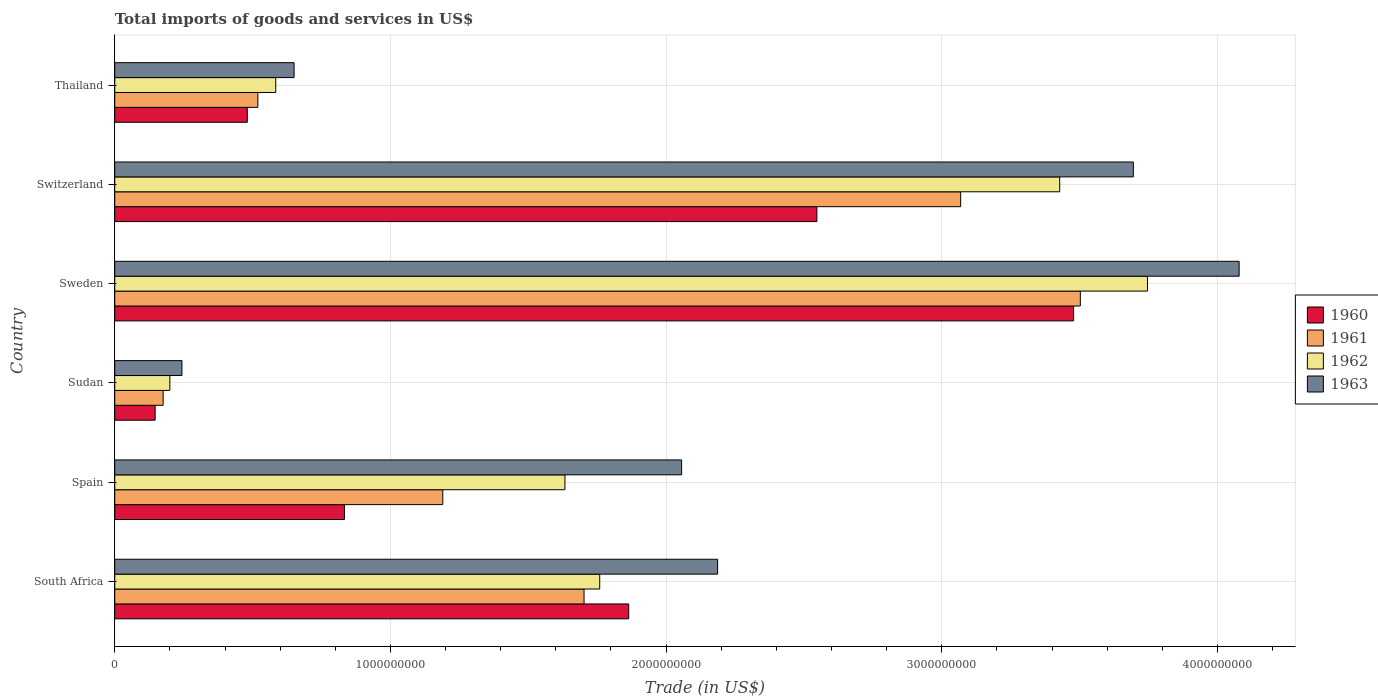How many groups of bars are there?
Keep it short and to the point. 6. Are the number of bars per tick equal to the number of legend labels?
Provide a succinct answer. Yes. Are the number of bars on each tick of the Y-axis equal?
Ensure brevity in your answer.  Yes. How many bars are there on the 5th tick from the top?
Make the answer very short. 4. What is the label of the 6th group of bars from the top?
Your answer should be compact. South Africa. What is the total imports of goods and services in 1963 in Sweden?
Provide a short and direct response. 4.08e+09. Across all countries, what is the maximum total imports of goods and services in 1961?
Ensure brevity in your answer.  3.50e+09. Across all countries, what is the minimum total imports of goods and services in 1960?
Offer a terse response. 1.46e+08. In which country was the total imports of goods and services in 1960 maximum?
Your answer should be compact. Sweden. In which country was the total imports of goods and services in 1961 minimum?
Make the answer very short. Sudan. What is the total total imports of goods and services in 1962 in the graph?
Offer a very short reply. 1.13e+1. What is the difference between the total imports of goods and services in 1962 in Spain and that in Thailand?
Your response must be concise. 1.05e+09. What is the difference between the total imports of goods and services in 1960 in Switzerland and the total imports of goods and services in 1961 in Thailand?
Ensure brevity in your answer.  2.03e+09. What is the average total imports of goods and services in 1962 per country?
Give a very brief answer. 1.89e+09. What is the difference between the total imports of goods and services in 1963 and total imports of goods and services in 1960 in Sweden?
Provide a succinct answer. 6.00e+08. In how many countries, is the total imports of goods and services in 1962 greater than 1000000000 US$?
Your answer should be very brief. 4. What is the ratio of the total imports of goods and services in 1963 in South Africa to that in Switzerland?
Keep it short and to the point. 0.59. What is the difference between the highest and the second highest total imports of goods and services in 1963?
Provide a short and direct response. 3.84e+08. What is the difference between the highest and the lowest total imports of goods and services in 1963?
Your response must be concise. 3.83e+09. Is the sum of the total imports of goods and services in 1963 in Spain and Thailand greater than the maximum total imports of goods and services in 1962 across all countries?
Offer a very short reply. No. What does the 1st bar from the bottom in Thailand represents?
Your answer should be very brief. 1960. Is it the case that in every country, the sum of the total imports of goods and services in 1962 and total imports of goods and services in 1961 is greater than the total imports of goods and services in 1963?
Your response must be concise. Yes. How many countries are there in the graph?
Offer a terse response. 6. Are the values on the major ticks of X-axis written in scientific E-notation?
Provide a succinct answer. No. Does the graph contain any zero values?
Ensure brevity in your answer.  No. Does the graph contain grids?
Ensure brevity in your answer.  Yes. How are the legend labels stacked?
Provide a short and direct response. Vertical. What is the title of the graph?
Give a very brief answer. Total imports of goods and services in US$. What is the label or title of the X-axis?
Offer a terse response. Trade (in US$). What is the Trade (in US$) of 1960 in South Africa?
Offer a very short reply. 1.86e+09. What is the Trade (in US$) in 1961 in South Africa?
Make the answer very short. 1.70e+09. What is the Trade (in US$) in 1962 in South Africa?
Make the answer very short. 1.76e+09. What is the Trade (in US$) of 1963 in South Africa?
Make the answer very short. 2.19e+09. What is the Trade (in US$) in 1960 in Spain?
Give a very brief answer. 8.33e+08. What is the Trade (in US$) of 1961 in Spain?
Your response must be concise. 1.19e+09. What is the Trade (in US$) in 1962 in Spain?
Provide a succinct answer. 1.63e+09. What is the Trade (in US$) in 1963 in Spain?
Offer a terse response. 2.06e+09. What is the Trade (in US$) in 1960 in Sudan?
Ensure brevity in your answer.  1.46e+08. What is the Trade (in US$) in 1961 in Sudan?
Offer a terse response. 1.75e+08. What is the Trade (in US$) of 1962 in Sudan?
Provide a short and direct response. 2.00e+08. What is the Trade (in US$) in 1963 in Sudan?
Provide a succinct answer. 2.44e+08. What is the Trade (in US$) of 1960 in Sweden?
Provide a succinct answer. 3.48e+09. What is the Trade (in US$) of 1961 in Sweden?
Give a very brief answer. 3.50e+09. What is the Trade (in US$) in 1962 in Sweden?
Offer a very short reply. 3.75e+09. What is the Trade (in US$) of 1963 in Sweden?
Make the answer very short. 4.08e+09. What is the Trade (in US$) in 1960 in Switzerland?
Give a very brief answer. 2.55e+09. What is the Trade (in US$) in 1961 in Switzerland?
Give a very brief answer. 3.07e+09. What is the Trade (in US$) of 1962 in Switzerland?
Offer a very short reply. 3.43e+09. What is the Trade (in US$) in 1963 in Switzerland?
Keep it short and to the point. 3.69e+09. What is the Trade (in US$) in 1960 in Thailand?
Give a very brief answer. 4.81e+08. What is the Trade (in US$) of 1961 in Thailand?
Give a very brief answer. 5.19e+08. What is the Trade (in US$) in 1962 in Thailand?
Provide a succinct answer. 5.84e+08. What is the Trade (in US$) in 1963 in Thailand?
Give a very brief answer. 6.51e+08. Across all countries, what is the maximum Trade (in US$) of 1960?
Offer a very short reply. 3.48e+09. Across all countries, what is the maximum Trade (in US$) of 1961?
Offer a terse response. 3.50e+09. Across all countries, what is the maximum Trade (in US$) of 1962?
Your response must be concise. 3.75e+09. Across all countries, what is the maximum Trade (in US$) in 1963?
Your answer should be very brief. 4.08e+09. Across all countries, what is the minimum Trade (in US$) of 1960?
Your answer should be very brief. 1.46e+08. Across all countries, what is the minimum Trade (in US$) of 1961?
Provide a short and direct response. 1.75e+08. Across all countries, what is the minimum Trade (in US$) of 1962?
Provide a succinct answer. 2.00e+08. Across all countries, what is the minimum Trade (in US$) in 1963?
Keep it short and to the point. 2.44e+08. What is the total Trade (in US$) of 1960 in the graph?
Your response must be concise. 9.35e+09. What is the total Trade (in US$) in 1961 in the graph?
Your answer should be compact. 1.02e+1. What is the total Trade (in US$) of 1962 in the graph?
Offer a very short reply. 1.13e+1. What is the total Trade (in US$) in 1963 in the graph?
Provide a short and direct response. 1.29e+1. What is the difference between the Trade (in US$) in 1960 in South Africa and that in Spain?
Ensure brevity in your answer.  1.03e+09. What is the difference between the Trade (in US$) of 1961 in South Africa and that in Spain?
Your answer should be compact. 5.12e+08. What is the difference between the Trade (in US$) in 1962 in South Africa and that in Spain?
Ensure brevity in your answer.  1.26e+08. What is the difference between the Trade (in US$) in 1963 in South Africa and that in Spain?
Keep it short and to the point. 1.31e+08. What is the difference between the Trade (in US$) in 1960 in South Africa and that in Sudan?
Give a very brief answer. 1.72e+09. What is the difference between the Trade (in US$) in 1961 in South Africa and that in Sudan?
Offer a very short reply. 1.53e+09. What is the difference between the Trade (in US$) of 1962 in South Africa and that in Sudan?
Your answer should be very brief. 1.56e+09. What is the difference between the Trade (in US$) in 1963 in South Africa and that in Sudan?
Provide a succinct answer. 1.94e+09. What is the difference between the Trade (in US$) of 1960 in South Africa and that in Sweden?
Offer a very short reply. -1.61e+09. What is the difference between the Trade (in US$) of 1961 in South Africa and that in Sweden?
Offer a terse response. -1.80e+09. What is the difference between the Trade (in US$) in 1962 in South Africa and that in Sweden?
Your response must be concise. -1.99e+09. What is the difference between the Trade (in US$) of 1963 in South Africa and that in Sweden?
Ensure brevity in your answer.  -1.89e+09. What is the difference between the Trade (in US$) of 1960 in South Africa and that in Switzerland?
Offer a very short reply. -6.83e+08. What is the difference between the Trade (in US$) in 1961 in South Africa and that in Switzerland?
Your response must be concise. -1.37e+09. What is the difference between the Trade (in US$) in 1962 in South Africa and that in Switzerland?
Provide a short and direct response. -1.67e+09. What is the difference between the Trade (in US$) of 1963 in South Africa and that in Switzerland?
Offer a terse response. -1.51e+09. What is the difference between the Trade (in US$) in 1960 in South Africa and that in Thailand?
Ensure brevity in your answer.  1.38e+09. What is the difference between the Trade (in US$) of 1961 in South Africa and that in Thailand?
Make the answer very short. 1.18e+09. What is the difference between the Trade (in US$) of 1962 in South Africa and that in Thailand?
Give a very brief answer. 1.18e+09. What is the difference between the Trade (in US$) in 1963 in South Africa and that in Thailand?
Offer a terse response. 1.54e+09. What is the difference between the Trade (in US$) in 1960 in Spain and that in Sudan?
Your answer should be compact. 6.87e+08. What is the difference between the Trade (in US$) in 1961 in Spain and that in Sudan?
Provide a succinct answer. 1.01e+09. What is the difference between the Trade (in US$) in 1962 in Spain and that in Sudan?
Keep it short and to the point. 1.43e+09. What is the difference between the Trade (in US$) of 1963 in Spain and that in Sudan?
Give a very brief answer. 1.81e+09. What is the difference between the Trade (in US$) of 1960 in Spain and that in Sweden?
Keep it short and to the point. -2.65e+09. What is the difference between the Trade (in US$) in 1961 in Spain and that in Sweden?
Offer a very short reply. -2.31e+09. What is the difference between the Trade (in US$) in 1962 in Spain and that in Sweden?
Your answer should be compact. -2.11e+09. What is the difference between the Trade (in US$) in 1963 in Spain and that in Sweden?
Keep it short and to the point. -2.02e+09. What is the difference between the Trade (in US$) of 1960 in Spain and that in Switzerland?
Offer a very short reply. -1.71e+09. What is the difference between the Trade (in US$) of 1961 in Spain and that in Switzerland?
Ensure brevity in your answer.  -1.88e+09. What is the difference between the Trade (in US$) of 1962 in Spain and that in Switzerland?
Your response must be concise. -1.79e+09. What is the difference between the Trade (in US$) in 1963 in Spain and that in Switzerland?
Provide a succinct answer. -1.64e+09. What is the difference between the Trade (in US$) of 1960 in Spain and that in Thailand?
Your response must be concise. 3.52e+08. What is the difference between the Trade (in US$) of 1961 in Spain and that in Thailand?
Provide a short and direct response. 6.71e+08. What is the difference between the Trade (in US$) in 1962 in Spain and that in Thailand?
Your answer should be compact. 1.05e+09. What is the difference between the Trade (in US$) in 1963 in Spain and that in Thailand?
Your answer should be compact. 1.41e+09. What is the difference between the Trade (in US$) of 1960 in Sudan and that in Sweden?
Your answer should be compact. -3.33e+09. What is the difference between the Trade (in US$) of 1961 in Sudan and that in Sweden?
Your answer should be compact. -3.33e+09. What is the difference between the Trade (in US$) of 1962 in Sudan and that in Sweden?
Keep it short and to the point. -3.55e+09. What is the difference between the Trade (in US$) in 1963 in Sudan and that in Sweden?
Make the answer very short. -3.83e+09. What is the difference between the Trade (in US$) in 1960 in Sudan and that in Switzerland?
Offer a very short reply. -2.40e+09. What is the difference between the Trade (in US$) in 1961 in Sudan and that in Switzerland?
Give a very brief answer. -2.89e+09. What is the difference between the Trade (in US$) in 1962 in Sudan and that in Switzerland?
Make the answer very short. -3.23e+09. What is the difference between the Trade (in US$) in 1963 in Sudan and that in Switzerland?
Offer a terse response. -3.45e+09. What is the difference between the Trade (in US$) in 1960 in Sudan and that in Thailand?
Your answer should be very brief. -3.34e+08. What is the difference between the Trade (in US$) of 1961 in Sudan and that in Thailand?
Your response must be concise. -3.44e+08. What is the difference between the Trade (in US$) in 1962 in Sudan and that in Thailand?
Give a very brief answer. -3.84e+08. What is the difference between the Trade (in US$) of 1963 in Sudan and that in Thailand?
Offer a terse response. -4.07e+08. What is the difference between the Trade (in US$) of 1960 in Sweden and that in Switzerland?
Make the answer very short. 9.31e+08. What is the difference between the Trade (in US$) in 1961 in Sweden and that in Switzerland?
Offer a terse response. 4.34e+08. What is the difference between the Trade (in US$) of 1962 in Sweden and that in Switzerland?
Keep it short and to the point. 3.18e+08. What is the difference between the Trade (in US$) in 1963 in Sweden and that in Switzerland?
Provide a short and direct response. 3.84e+08. What is the difference between the Trade (in US$) in 1960 in Sweden and that in Thailand?
Ensure brevity in your answer.  3.00e+09. What is the difference between the Trade (in US$) of 1961 in Sweden and that in Thailand?
Offer a very short reply. 2.98e+09. What is the difference between the Trade (in US$) of 1962 in Sweden and that in Thailand?
Keep it short and to the point. 3.16e+09. What is the difference between the Trade (in US$) in 1963 in Sweden and that in Thailand?
Your response must be concise. 3.43e+09. What is the difference between the Trade (in US$) of 1960 in Switzerland and that in Thailand?
Ensure brevity in your answer.  2.07e+09. What is the difference between the Trade (in US$) in 1961 in Switzerland and that in Thailand?
Your response must be concise. 2.55e+09. What is the difference between the Trade (in US$) in 1962 in Switzerland and that in Thailand?
Your answer should be compact. 2.84e+09. What is the difference between the Trade (in US$) in 1963 in Switzerland and that in Thailand?
Your response must be concise. 3.04e+09. What is the difference between the Trade (in US$) of 1960 in South Africa and the Trade (in US$) of 1961 in Spain?
Offer a very short reply. 6.74e+08. What is the difference between the Trade (in US$) in 1960 in South Africa and the Trade (in US$) in 1962 in Spain?
Make the answer very short. 2.31e+08. What is the difference between the Trade (in US$) of 1960 in South Africa and the Trade (in US$) of 1963 in Spain?
Offer a very short reply. -1.92e+08. What is the difference between the Trade (in US$) in 1961 in South Africa and the Trade (in US$) in 1962 in Spain?
Offer a terse response. 6.92e+07. What is the difference between the Trade (in US$) in 1961 in South Africa and the Trade (in US$) in 1963 in Spain?
Provide a short and direct response. -3.54e+08. What is the difference between the Trade (in US$) of 1962 in South Africa and the Trade (in US$) of 1963 in Spain?
Your response must be concise. -2.97e+08. What is the difference between the Trade (in US$) in 1960 in South Africa and the Trade (in US$) in 1961 in Sudan?
Provide a short and direct response. 1.69e+09. What is the difference between the Trade (in US$) in 1960 in South Africa and the Trade (in US$) in 1962 in Sudan?
Your answer should be compact. 1.66e+09. What is the difference between the Trade (in US$) in 1960 in South Africa and the Trade (in US$) in 1963 in Sudan?
Offer a terse response. 1.62e+09. What is the difference between the Trade (in US$) in 1961 in South Africa and the Trade (in US$) in 1962 in Sudan?
Provide a succinct answer. 1.50e+09. What is the difference between the Trade (in US$) in 1961 in South Africa and the Trade (in US$) in 1963 in Sudan?
Ensure brevity in your answer.  1.46e+09. What is the difference between the Trade (in US$) in 1962 in South Africa and the Trade (in US$) in 1963 in Sudan?
Make the answer very short. 1.52e+09. What is the difference between the Trade (in US$) in 1960 in South Africa and the Trade (in US$) in 1961 in Sweden?
Provide a short and direct response. -1.64e+09. What is the difference between the Trade (in US$) in 1960 in South Africa and the Trade (in US$) in 1962 in Sweden?
Provide a succinct answer. -1.88e+09. What is the difference between the Trade (in US$) of 1960 in South Africa and the Trade (in US$) of 1963 in Sweden?
Your response must be concise. -2.21e+09. What is the difference between the Trade (in US$) of 1961 in South Africa and the Trade (in US$) of 1962 in Sweden?
Give a very brief answer. -2.04e+09. What is the difference between the Trade (in US$) of 1961 in South Africa and the Trade (in US$) of 1963 in Sweden?
Ensure brevity in your answer.  -2.38e+09. What is the difference between the Trade (in US$) of 1962 in South Africa and the Trade (in US$) of 1963 in Sweden?
Your response must be concise. -2.32e+09. What is the difference between the Trade (in US$) of 1960 in South Africa and the Trade (in US$) of 1961 in Switzerland?
Your response must be concise. -1.20e+09. What is the difference between the Trade (in US$) of 1960 in South Africa and the Trade (in US$) of 1962 in Switzerland?
Your answer should be very brief. -1.56e+09. What is the difference between the Trade (in US$) of 1960 in South Africa and the Trade (in US$) of 1963 in Switzerland?
Give a very brief answer. -1.83e+09. What is the difference between the Trade (in US$) of 1961 in South Africa and the Trade (in US$) of 1962 in Switzerland?
Make the answer very short. -1.73e+09. What is the difference between the Trade (in US$) of 1961 in South Africa and the Trade (in US$) of 1963 in Switzerland?
Keep it short and to the point. -1.99e+09. What is the difference between the Trade (in US$) of 1962 in South Africa and the Trade (in US$) of 1963 in Switzerland?
Your response must be concise. -1.94e+09. What is the difference between the Trade (in US$) of 1960 in South Africa and the Trade (in US$) of 1961 in Thailand?
Offer a terse response. 1.35e+09. What is the difference between the Trade (in US$) in 1960 in South Africa and the Trade (in US$) in 1962 in Thailand?
Provide a succinct answer. 1.28e+09. What is the difference between the Trade (in US$) of 1960 in South Africa and the Trade (in US$) of 1963 in Thailand?
Offer a very short reply. 1.21e+09. What is the difference between the Trade (in US$) of 1961 in South Africa and the Trade (in US$) of 1962 in Thailand?
Offer a very short reply. 1.12e+09. What is the difference between the Trade (in US$) in 1961 in South Africa and the Trade (in US$) in 1963 in Thailand?
Keep it short and to the point. 1.05e+09. What is the difference between the Trade (in US$) of 1962 in South Africa and the Trade (in US$) of 1963 in Thailand?
Your response must be concise. 1.11e+09. What is the difference between the Trade (in US$) of 1960 in Spain and the Trade (in US$) of 1961 in Sudan?
Provide a short and direct response. 6.58e+08. What is the difference between the Trade (in US$) in 1960 in Spain and the Trade (in US$) in 1962 in Sudan?
Make the answer very short. 6.33e+08. What is the difference between the Trade (in US$) of 1960 in Spain and the Trade (in US$) of 1963 in Sudan?
Your answer should be very brief. 5.89e+08. What is the difference between the Trade (in US$) of 1961 in Spain and the Trade (in US$) of 1962 in Sudan?
Your response must be concise. 9.90e+08. What is the difference between the Trade (in US$) of 1961 in Spain and the Trade (in US$) of 1963 in Sudan?
Keep it short and to the point. 9.46e+08. What is the difference between the Trade (in US$) in 1962 in Spain and the Trade (in US$) in 1963 in Sudan?
Offer a terse response. 1.39e+09. What is the difference between the Trade (in US$) in 1960 in Spain and the Trade (in US$) in 1961 in Sweden?
Your answer should be very brief. -2.67e+09. What is the difference between the Trade (in US$) in 1960 in Spain and the Trade (in US$) in 1962 in Sweden?
Ensure brevity in your answer.  -2.91e+09. What is the difference between the Trade (in US$) in 1960 in Spain and the Trade (in US$) in 1963 in Sweden?
Your response must be concise. -3.25e+09. What is the difference between the Trade (in US$) in 1961 in Spain and the Trade (in US$) in 1962 in Sweden?
Give a very brief answer. -2.56e+09. What is the difference between the Trade (in US$) in 1961 in Spain and the Trade (in US$) in 1963 in Sweden?
Ensure brevity in your answer.  -2.89e+09. What is the difference between the Trade (in US$) of 1962 in Spain and the Trade (in US$) of 1963 in Sweden?
Make the answer very short. -2.45e+09. What is the difference between the Trade (in US$) of 1960 in Spain and the Trade (in US$) of 1961 in Switzerland?
Give a very brief answer. -2.24e+09. What is the difference between the Trade (in US$) of 1960 in Spain and the Trade (in US$) of 1962 in Switzerland?
Keep it short and to the point. -2.59e+09. What is the difference between the Trade (in US$) in 1960 in Spain and the Trade (in US$) in 1963 in Switzerland?
Offer a very short reply. -2.86e+09. What is the difference between the Trade (in US$) in 1961 in Spain and the Trade (in US$) in 1962 in Switzerland?
Your answer should be compact. -2.24e+09. What is the difference between the Trade (in US$) of 1961 in Spain and the Trade (in US$) of 1963 in Switzerland?
Your answer should be very brief. -2.50e+09. What is the difference between the Trade (in US$) in 1962 in Spain and the Trade (in US$) in 1963 in Switzerland?
Keep it short and to the point. -2.06e+09. What is the difference between the Trade (in US$) of 1960 in Spain and the Trade (in US$) of 1961 in Thailand?
Provide a succinct answer. 3.14e+08. What is the difference between the Trade (in US$) in 1960 in Spain and the Trade (in US$) in 1962 in Thailand?
Provide a succinct answer. 2.49e+08. What is the difference between the Trade (in US$) of 1960 in Spain and the Trade (in US$) of 1963 in Thailand?
Ensure brevity in your answer.  1.83e+08. What is the difference between the Trade (in US$) of 1961 in Spain and the Trade (in US$) of 1962 in Thailand?
Provide a succinct answer. 6.06e+08. What is the difference between the Trade (in US$) of 1961 in Spain and the Trade (in US$) of 1963 in Thailand?
Provide a succinct answer. 5.39e+08. What is the difference between the Trade (in US$) of 1962 in Spain and the Trade (in US$) of 1963 in Thailand?
Your answer should be compact. 9.83e+08. What is the difference between the Trade (in US$) of 1960 in Sudan and the Trade (in US$) of 1961 in Sweden?
Your response must be concise. -3.36e+09. What is the difference between the Trade (in US$) of 1960 in Sudan and the Trade (in US$) of 1962 in Sweden?
Give a very brief answer. -3.60e+09. What is the difference between the Trade (in US$) in 1960 in Sudan and the Trade (in US$) in 1963 in Sweden?
Your response must be concise. -3.93e+09. What is the difference between the Trade (in US$) in 1961 in Sudan and the Trade (in US$) in 1962 in Sweden?
Your answer should be compact. -3.57e+09. What is the difference between the Trade (in US$) of 1961 in Sudan and the Trade (in US$) of 1963 in Sweden?
Provide a short and direct response. -3.90e+09. What is the difference between the Trade (in US$) in 1962 in Sudan and the Trade (in US$) in 1963 in Sweden?
Your answer should be very brief. -3.88e+09. What is the difference between the Trade (in US$) in 1960 in Sudan and the Trade (in US$) in 1961 in Switzerland?
Give a very brief answer. -2.92e+09. What is the difference between the Trade (in US$) in 1960 in Sudan and the Trade (in US$) in 1962 in Switzerland?
Your answer should be compact. -3.28e+09. What is the difference between the Trade (in US$) in 1960 in Sudan and the Trade (in US$) in 1963 in Switzerland?
Keep it short and to the point. -3.55e+09. What is the difference between the Trade (in US$) of 1961 in Sudan and the Trade (in US$) of 1962 in Switzerland?
Provide a succinct answer. -3.25e+09. What is the difference between the Trade (in US$) of 1961 in Sudan and the Trade (in US$) of 1963 in Switzerland?
Offer a terse response. -3.52e+09. What is the difference between the Trade (in US$) of 1962 in Sudan and the Trade (in US$) of 1963 in Switzerland?
Keep it short and to the point. -3.49e+09. What is the difference between the Trade (in US$) in 1960 in Sudan and the Trade (in US$) in 1961 in Thailand?
Your response must be concise. -3.73e+08. What is the difference between the Trade (in US$) in 1960 in Sudan and the Trade (in US$) in 1962 in Thailand?
Your response must be concise. -4.38e+08. What is the difference between the Trade (in US$) of 1960 in Sudan and the Trade (in US$) of 1963 in Thailand?
Offer a terse response. -5.04e+08. What is the difference between the Trade (in US$) of 1961 in Sudan and the Trade (in US$) of 1962 in Thailand?
Your response must be concise. -4.09e+08. What is the difference between the Trade (in US$) of 1961 in Sudan and the Trade (in US$) of 1963 in Thailand?
Ensure brevity in your answer.  -4.75e+08. What is the difference between the Trade (in US$) in 1962 in Sudan and the Trade (in US$) in 1963 in Thailand?
Your answer should be very brief. -4.51e+08. What is the difference between the Trade (in US$) in 1960 in Sweden and the Trade (in US$) in 1961 in Switzerland?
Make the answer very short. 4.10e+08. What is the difference between the Trade (in US$) of 1960 in Sweden and the Trade (in US$) of 1962 in Switzerland?
Offer a terse response. 5.05e+07. What is the difference between the Trade (in US$) in 1960 in Sweden and the Trade (in US$) in 1963 in Switzerland?
Keep it short and to the point. -2.17e+08. What is the difference between the Trade (in US$) of 1961 in Sweden and the Trade (in US$) of 1962 in Switzerland?
Give a very brief answer. 7.48e+07. What is the difference between the Trade (in US$) in 1961 in Sweden and the Trade (in US$) in 1963 in Switzerland?
Offer a very short reply. -1.92e+08. What is the difference between the Trade (in US$) in 1962 in Sweden and the Trade (in US$) in 1963 in Switzerland?
Your response must be concise. 5.13e+07. What is the difference between the Trade (in US$) of 1960 in Sweden and the Trade (in US$) of 1961 in Thailand?
Make the answer very short. 2.96e+09. What is the difference between the Trade (in US$) of 1960 in Sweden and the Trade (in US$) of 1962 in Thailand?
Provide a short and direct response. 2.89e+09. What is the difference between the Trade (in US$) in 1960 in Sweden and the Trade (in US$) in 1963 in Thailand?
Give a very brief answer. 2.83e+09. What is the difference between the Trade (in US$) of 1961 in Sweden and the Trade (in US$) of 1962 in Thailand?
Your response must be concise. 2.92e+09. What is the difference between the Trade (in US$) in 1961 in Sweden and the Trade (in US$) in 1963 in Thailand?
Provide a short and direct response. 2.85e+09. What is the difference between the Trade (in US$) of 1962 in Sweden and the Trade (in US$) of 1963 in Thailand?
Your answer should be compact. 3.10e+09. What is the difference between the Trade (in US$) of 1960 in Switzerland and the Trade (in US$) of 1961 in Thailand?
Your answer should be very brief. 2.03e+09. What is the difference between the Trade (in US$) in 1960 in Switzerland and the Trade (in US$) in 1962 in Thailand?
Offer a terse response. 1.96e+09. What is the difference between the Trade (in US$) in 1960 in Switzerland and the Trade (in US$) in 1963 in Thailand?
Your answer should be compact. 1.90e+09. What is the difference between the Trade (in US$) of 1961 in Switzerland and the Trade (in US$) of 1962 in Thailand?
Your answer should be compact. 2.48e+09. What is the difference between the Trade (in US$) in 1961 in Switzerland and the Trade (in US$) in 1963 in Thailand?
Make the answer very short. 2.42e+09. What is the difference between the Trade (in US$) of 1962 in Switzerland and the Trade (in US$) of 1963 in Thailand?
Your answer should be compact. 2.78e+09. What is the average Trade (in US$) in 1960 per country?
Keep it short and to the point. 1.56e+09. What is the average Trade (in US$) of 1961 per country?
Keep it short and to the point. 1.69e+09. What is the average Trade (in US$) in 1962 per country?
Provide a succinct answer. 1.89e+09. What is the average Trade (in US$) of 1963 per country?
Make the answer very short. 2.15e+09. What is the difference between the Trade (in US$) in 1960 and Trade (in US$) in 1961 in South Africa?
Provide a succinct answer. 1.62e+08. What is the difference between the Trade (in US$) in 1960 and Trade (in US$) in 1962 in South Africa?
Your response must be concise. 1.05e+08. What is the difference between the Trade (in US$) in 1960 and Trade (in US$) in 1963 in South Africa?
Offer a terse response. -3.23e+08. What is the difference between the Trade (in US$) in 1961 and Trade (in US$) in 1962 in South Africa?
Ensure brevity in your answer.  -5.68e+07. What is the difference between the Trade (in US$) of 1961 and Trade (in US$) of 1963 in South Africa?
Make the answer very short. -4.85e+08. What is the difference between the Trade (in US$) in 1962 and Trade (in US$) in 1963 in South Africa?
Make the answer very short. -4.28e+08. What is the difference between the Trade (in US$) in 1960 and Trade (in US$) in 1961 in Spain?
Your answer should be very brief. -3.57e+08. What is the difference between the Trade (in US$) of 1960 and Trade (in US$) of 1962 in Spain?
Your answer should be compact. -8.00e+08. What is the difference between the Trade (in US$) of 1960 and Trade (in US$) of 1963 in Spain?
Your answer should be very brief. -1.22e+09. What is the difference between the Trade (in US$) in 1961 and Trade (in US$) in 1962 in Spain?
Offer a very short reply. -4.43e+08. What is the difference between the Trade (in US$) of 1961 and Trade (in US$) of 1963 in Spain?
Offer a very short reply. -8.66e+08. What is the difference between the Trade (in US$) of 1962 and Trade (in US$) of 1963 in Spain?
Ensure brevity in your answer.  -4.23e+08. What is the difference between the Trade (in US$) in 1960 and Trade (in US$) in 1961 in Sudan?
Ensure brevity in your answer.  -2.90e+07. What is the difference between the Trade (in US$) of 1960 and Trade (in US$) of 1962 in Sudan?
Offer a very short reply. -5.34e+07. What is the difference between the Trade (in US$) in 1960 and Trade (in US$) in 1963 in Sudan?
Your response must be concise. -9.74e+07. What is the difference between the Trade (in US$) of 1961 and Trade (in US$) of 1962 in Sudan?
Offer a very short reply. -2.44e+07. What is the difference between the Trade (in US$) of 1961 and Trade (in US$) of 1963 in Sudan?
Provide a short and direct response. -6.84e+07. What is the difference between the Trade (in US$) in 1962 and Trade (in US$) in 1963 in Sudan?
Your response must be concise. -4.39e+07. What is the difference between the Trade (in US$) of 1960 and Trade (in US$) of 1961 in Sweden?
Keep it short and to the point. -2.44e+07. What is the difference between the Trade (in US$) in 1960 and Trade (in US$) in 1962 in Sweden?
Offer a very short reply. -2.68e+08. What is the difference between the Trade (in US$) of 1960 and Trade (in US$) of 1963 in Sweden?
Your answer should be very brief. -6.00e+08. What is the difference between the Trade (in US$) in 1961 and Trade (in US$) in 1962 in Sweden?
Your answer should be compact. -2.44e+08. What is the difference between the Trade (in US$) of 1961 and Trade (in US$) of 1963 in Sweden?
Your answer should be compact. -5.76e+08. What is the difference between the Trade (in US$) of 1962 and Trade (in US$) of 1963 in Sweden?
Your response must be concise. -3.33e+08. What is the difference between the Trade (in US$) of 1960 and Trade (in US$) of 1961 in Switzerland?
Give a very brief answer. -5.22e+08. What is the difference between the Trade (in US$) in 1960 and Trade (in US$) in 1962 in Switzerland?
Your response must be concise. -8.81e+08. What is the difference between the Trade (in US$) in 1960 and Trade (in US$) in 1963 in Switzerland?
Your answer should be compact. -1.15e+09. What is the difference between the Trade (in US$) in 1961 and Trade (in US$) in 1962 in Switzerland?
Give a very brief answer. -3.59e+08. What is the difference between the Trade (in US$) of 1961 and Trade (in US$) of 1963 in Switzerland?
Your answer should be compact. -6.26e+08. What is the difference between the Trade (in US$) of 1962 and Trade (in US$) of 1963 in Switzerland?
Offer a very short reply. -2.67e+08. What is the difference between the Trade (in US$) of 1960 and Trade (in US$) of 1961 in Thailand?
Offer a terse response. -3.83e+07. What is the difference between the Trade (in US$) of 1960 and Trade (in US$) of 1962 in Thailand?
Offer a very short reply. -1.03e+08. What is the difference between the Trade (in US$) in 1960 and Trade (in US$) in 1963 in Thailand?
Provide a succinct answer. -1.70e+08. What is the difference between the Trade (in US$) in 1961 and Trade (in US$) in 1962 in Thailand?
Provide a succinct answer. -6.49e+07. What is the difference between the Trade (in US$) of 1961 and Trade (in US$) of 1963 in Thailand?
Ensure brevity in your answer.  -1.31e+08. What is the difference between the Trade (in US$) in 1962 and Trade (in US$) in 1963 in Thailand?
Make the answer very short. -6.65e+07. What is the ratio of the Trade (in US$) of 1960 in South Africa to that in Spain?
Offer a very short reply. 2.24. What is the ratio of the Trade (in US$) in 1961 in South Africa to that in Spain?
Make the answer very short. 1.43. What is the ratio of the Trade (in US$) of 1962 in South Africa to that in Spain?
Keep it short and to the point. 1.08. What is the ratio of the Trade (in US$) in 1963 in South Africa to that in Spain?
Give a very brief answer. 1.06. What is the ratio of the Trade (in US$) of 1960 in South Africa to that in Sudan?
Your answer should be very brief. 12.73. What is the ratio of the Trade (in US$) of 1961 in South Africa to that in Sudan?
Give a very brief answer. 9.7. What is the ratio of the Trade (in US$) in 1962 in South Africa to that in Sudan?
Give a very brief answer. 8.8. What is the ratio of the Trade (in US$) of 1963 in South Africa to that in Sudan?
Make the answer very short. 8.97. What is the ratio of the Trade (in US$) of 1960 in South Africa to that in Sweden?
Ensure brevity in your answer.  0.54. What is the ratio of the Trade (in US$) in 1961 in South Africa to that in Sweden?
Offer a very short reply. 0.49. What is the ratio of the Trade (in US$) of 1962 in South Africa to that in Sweden?
Ensure brevity in your answer.  0.47. What is the ratio of the Trade (in US$) in 1963 in South Africa to that in Sweden?
Your answer should be compact. 0.54. What is the ratio of the Trade (in US$) in 1960 in South Africa to that in Switzerland?
Keep it short and to the point. 0.73. What is the ratio of the Trade (in US$) in 1961 in South Africa to that in Switzerland?
Offer a terse response. 0.55. What is the ratio of the Trade (in US$) of 1962 in South Africa to that in Switzerland?
Your answer should be very brief. 0.51. What is the ratio of the Trade (in US$) in 1963 in South Africa to that in Switzerland?
Your response must be concise. 0.59. What is the ratio of the Trade (in US$) in 1960 in South Africa to that in Thailand?
Your answer should be very brief. 3.88. What is the ratio of the Trade (in US$) in 1961 in South Africa to that in Thailand?
Provide a short and direct response. 3.28. What is the ratio of the Trade (in US$) in 1962 in South Africa to that in Thailand?
Give a very brief answer. 3.01. What is the ratio of the Trade (in US$) of 1963 in South Africa to that in Thailand?
Make the answer very short. 3.36. What is the ratio of the Trade (in US$) of 1960 in Spain to that in Sudan?
Provide a succinct answer. 5.69. What is the ratio of the Trade (in US$) of 1961 in Spain to that in Sudan?
Offer a very short reply. 6.78. What is the ratio of the Trade (in US$) in 1962 in Spain to that in Sudan?
Offer a terse response. 8.17. What is the ratio of the Trade (in US$) of 1963 in Spain to that in Sudan?
Keep it short and to the point. 8.43. What is the ratio of the Trade (in US$) in 1960 in Spain to that in Sweden?
Give a very brief answer. 0.24. What is the ratio of the Trade (in US$) of 1961 in Spain to that in Sweden?
Provide a succinct answer. 0.34. What is the ratio of the Trade (in US$) in 1962 in Spain to that in Sweden?
Give a very brief answer. 0.44. What is the ratio of the Trade (in US$) of 1963 in Spain to that in Sweden?
Your answer should be very brief. 0.5. What is the ratio of the Trade (in US$) in 1960 in Spain to that in Switzerland?
Provide a succinct answer. 0.33. What is the ratio of the Trade (in US$) of 1961 in Spain to that in Switzerland?
Your answer should be compact. 0.39. What is the ratio of the Trade (in US$) in 1962 in Spain to that in Switzerland?
Provide a succinct answer. 0.48. What is the ratio of the Trade (in US$) in 1963 in Spain to that in Switzerland?
Provide a succinct answer. 0.56. What is the ratio of the Trade (in US$) of 1960 in Spain to that in Thailand?
Your answer should be very brief. 1.73. What is the ratio of the Trade (in US$) in 1961 in Spain to that in Thailand?
Provide a succinct answer. 2.29. What is the ratio of the Trade (in US$) in 1962 in Spain to that in Thailand?
Keep it short and to the point. 2.8. What is the ratio of the Trade (in US$) in 1963 in Spain to that in Thailand?
Your answer should be very brief. 3.16. What is the ratio of the Trade (in US$) in 1960 in Sudan to that in Sweden?
Your answer should be compact. 0.04. What is the ratio of the Trade (in US$) of 1961 in Sudan to that in Sweden?
Ensure brevity in your answer.  0.05. What is the ratio of the Trade (in US$) of 1962 in Sudan to that in Sweden?
Offer a terse response. 0.05. What is the ratio of the Trade (in US$) in 1963 in Sudan to that in Sweden?
Your response must be concise. 0.06. What is the ratio of the Trade (in US$) in 1960 in Sudan to that in Switzerland?
Provide a succinct answer. 0.06. What is the ratio of the Trade (in US$) of 1961 in Sudan to that in Switzerland?
Provide a short and direct response. 0.06. What is the ratio of the Trade (in US$) of 1962 in Sudan to that in Switzerland?
Give a very brief answer. 0.06. What is the ratio of the Trade (in US$) of 1963 in Sudan to that in Switzerland?
Your answer should be very brief. 0.07. What is the ratio of the Trade (in US$) in 1960 in Sudan to that in Thailand?
Ensure brevity in your answer.  0.3. What is the ratio of the Trade (in US$) in 1961 in Sudan to that in Thailand?
Offer a terse response. 0.34. What is the ratio of the Trade (in US$) in 1962 in Sudan to that in Thailand?
Offer a terse response. 0.34. What is the ratio of the Trade (in US$) in 1963 in Sudan to that in Thailand?
Keep it short and to the point. 0.37. What is the ratio of the Trade (in US$) in 1960 in Sweden to that in Switzerland?
Make the answer very short. 1.37. What is the ratio of the Trade (in US$) in 1961 in Sweden to that in Switzerland?
Provide a succinct answer. 1.14. What is the ratio of the Trade (in US$) of 1962 in Sweden to that in Switzerland?
Offer a very short reply. 1.09. What is the ratio of the Trade (in US$) of 1963 in Sweden to that in Switzerland?
Provide a short and direct response. 1.1. What is the ratio of the Trade (in US$) in 1960 in Sweden to that in Thailand?
Keep it short and to the point. 7.23. What is the ratio of the Trade (in US$) of 1961 in Sweden to that in Thailand?
Keep it short and to the point. 6.75. What is the ratio of the Trade (in US$) in 1962 in Sweden to that in Thailand?
Offer a terse response. 6.41. What is the ratio of the Trade (in US$) of 1963 in Sweden to that in Thailand?
Your response must be concise. 6.27. What is the ratio of the Trade (in US$) of 1960 in Switzerland to that in Thailand?
Give a very brief answer. 5.3. What is the ratio of the Trade (in US$) of 1961 in Switzerland to that in Thailand?
Give a very brief answer. 5.91. What is the ratio of the Trade (in US$) of 1962 in Switzerland to that in Thailand?
Offer a terse response. 5.87. What is the ratio of the Trade (in US$) of 1963 in Switzerland to that in Thailand?
Your response must be concise. 5.68. What is the difference between the highest and the second highest Trade (in US$) in 1960?
Provide a short and direct response. 9.31e+08. What is the difference between the highest and the second highest Trade (in US$) of 1961?
Keep it short and to the point. 4.34e+08. What is the difference between the highest and the second highest Trade (in US$) in 1962?
Keep it short and to the point. 3.18e+08. What is the difference between the highest and the second highest Trade (in US$) of 1963?
Provide a succinct answer. 3.84e+08. What is the difference between the highest and the lowest Trade (in US$) in 1960?
Offer a terse response. 3.33e+09. What is the difference between the highest and the lowest Trade (in US$) in 1961?
Your response must be concise. 3.33e+09. What is the difference between the highest and the lowest Trade (in US$) of 1962?
Offer a very short reply. 3.55e+09. What is the difference between the highest and the lowest Trade (in US$) in 1963?
Provide a short and direct response. 3.83e+09. 